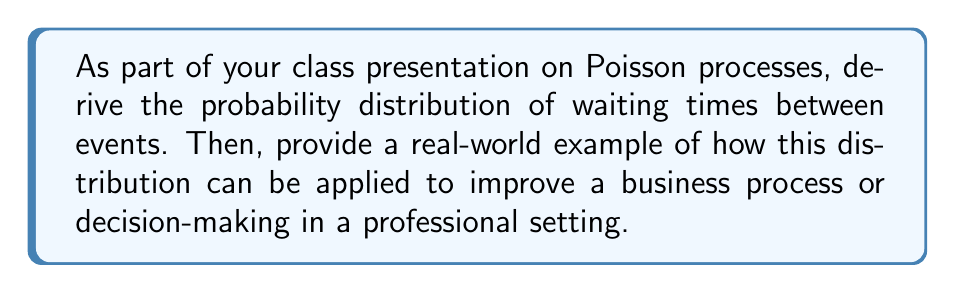Help me with this question. Let's approach this step-by-step:

1) In a Poisson process, events occur continuously and independently at a constant average rate λ.

2) Let T be the waiting time until the next event occurs. We want to find P(T > t), the probability that the waiting time exceeds t.

3) P(T > t) is equivalent to the probability of no events occurring in time interval t. In a Poisson process, this is given by:

   $P(T > t) = e^{-λt}$

4) The cumulative distribution function (CDF) of T is:

   $F_T(t) = P(T ≤ t) = 1 - P(T > t) = 1 - e^{-λt}$

5) To get the probability density function (PDF), we differentiate the CDF:

   $f_T(t) = \frac{d}{dt}F_T(t) = \frac{d}{dt}(1 - e^{-λt}) = λe^{-λt}$

6) This PDF is known as the exponential distribution with parameter λ.

7) The mean (expected value) of this distribution is:

   $E[T] = \frac{1}{λ}$

8) The variance is:

   $Var(T) = \frac{1}{λ^2}$

Real-world application:
Consider a call center that receives customer service calls. If the calls follow a Poisson process with rate λ calls per hour:

- The time between calls follows the exponential distribution derived above.
- Managers can use this to predict wait times and staff accordingly.
- For example, the probability of waiting more than t minutes for the next call is $e^{-λt}$.
- This can help in optimizing staffing levels, predicting busy periods, and improving overall customer service.
Answer: The waiting time T follows an exponential distribution with PDF $f_T(t) = λe^{-λt}$, where λ is the rate parameter of the Poisson process. 